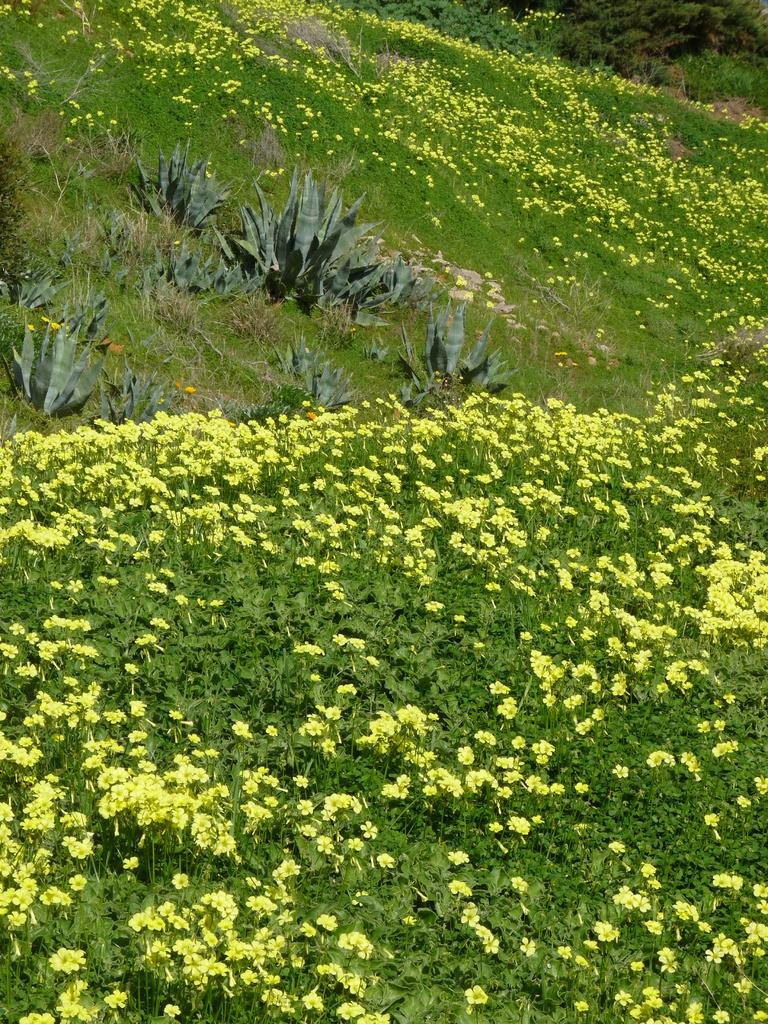What type of living organisms can be seen in the image? There are flowers in the image. Where are the flowers located? The flowers are on plants. What type of vegetation is visible in the image? There is grass visible in the image. How many dolls can be seen playing with boats in the light in the image? There are no dolls, boats, or light present in the image; it features flowers on plants and grass. 